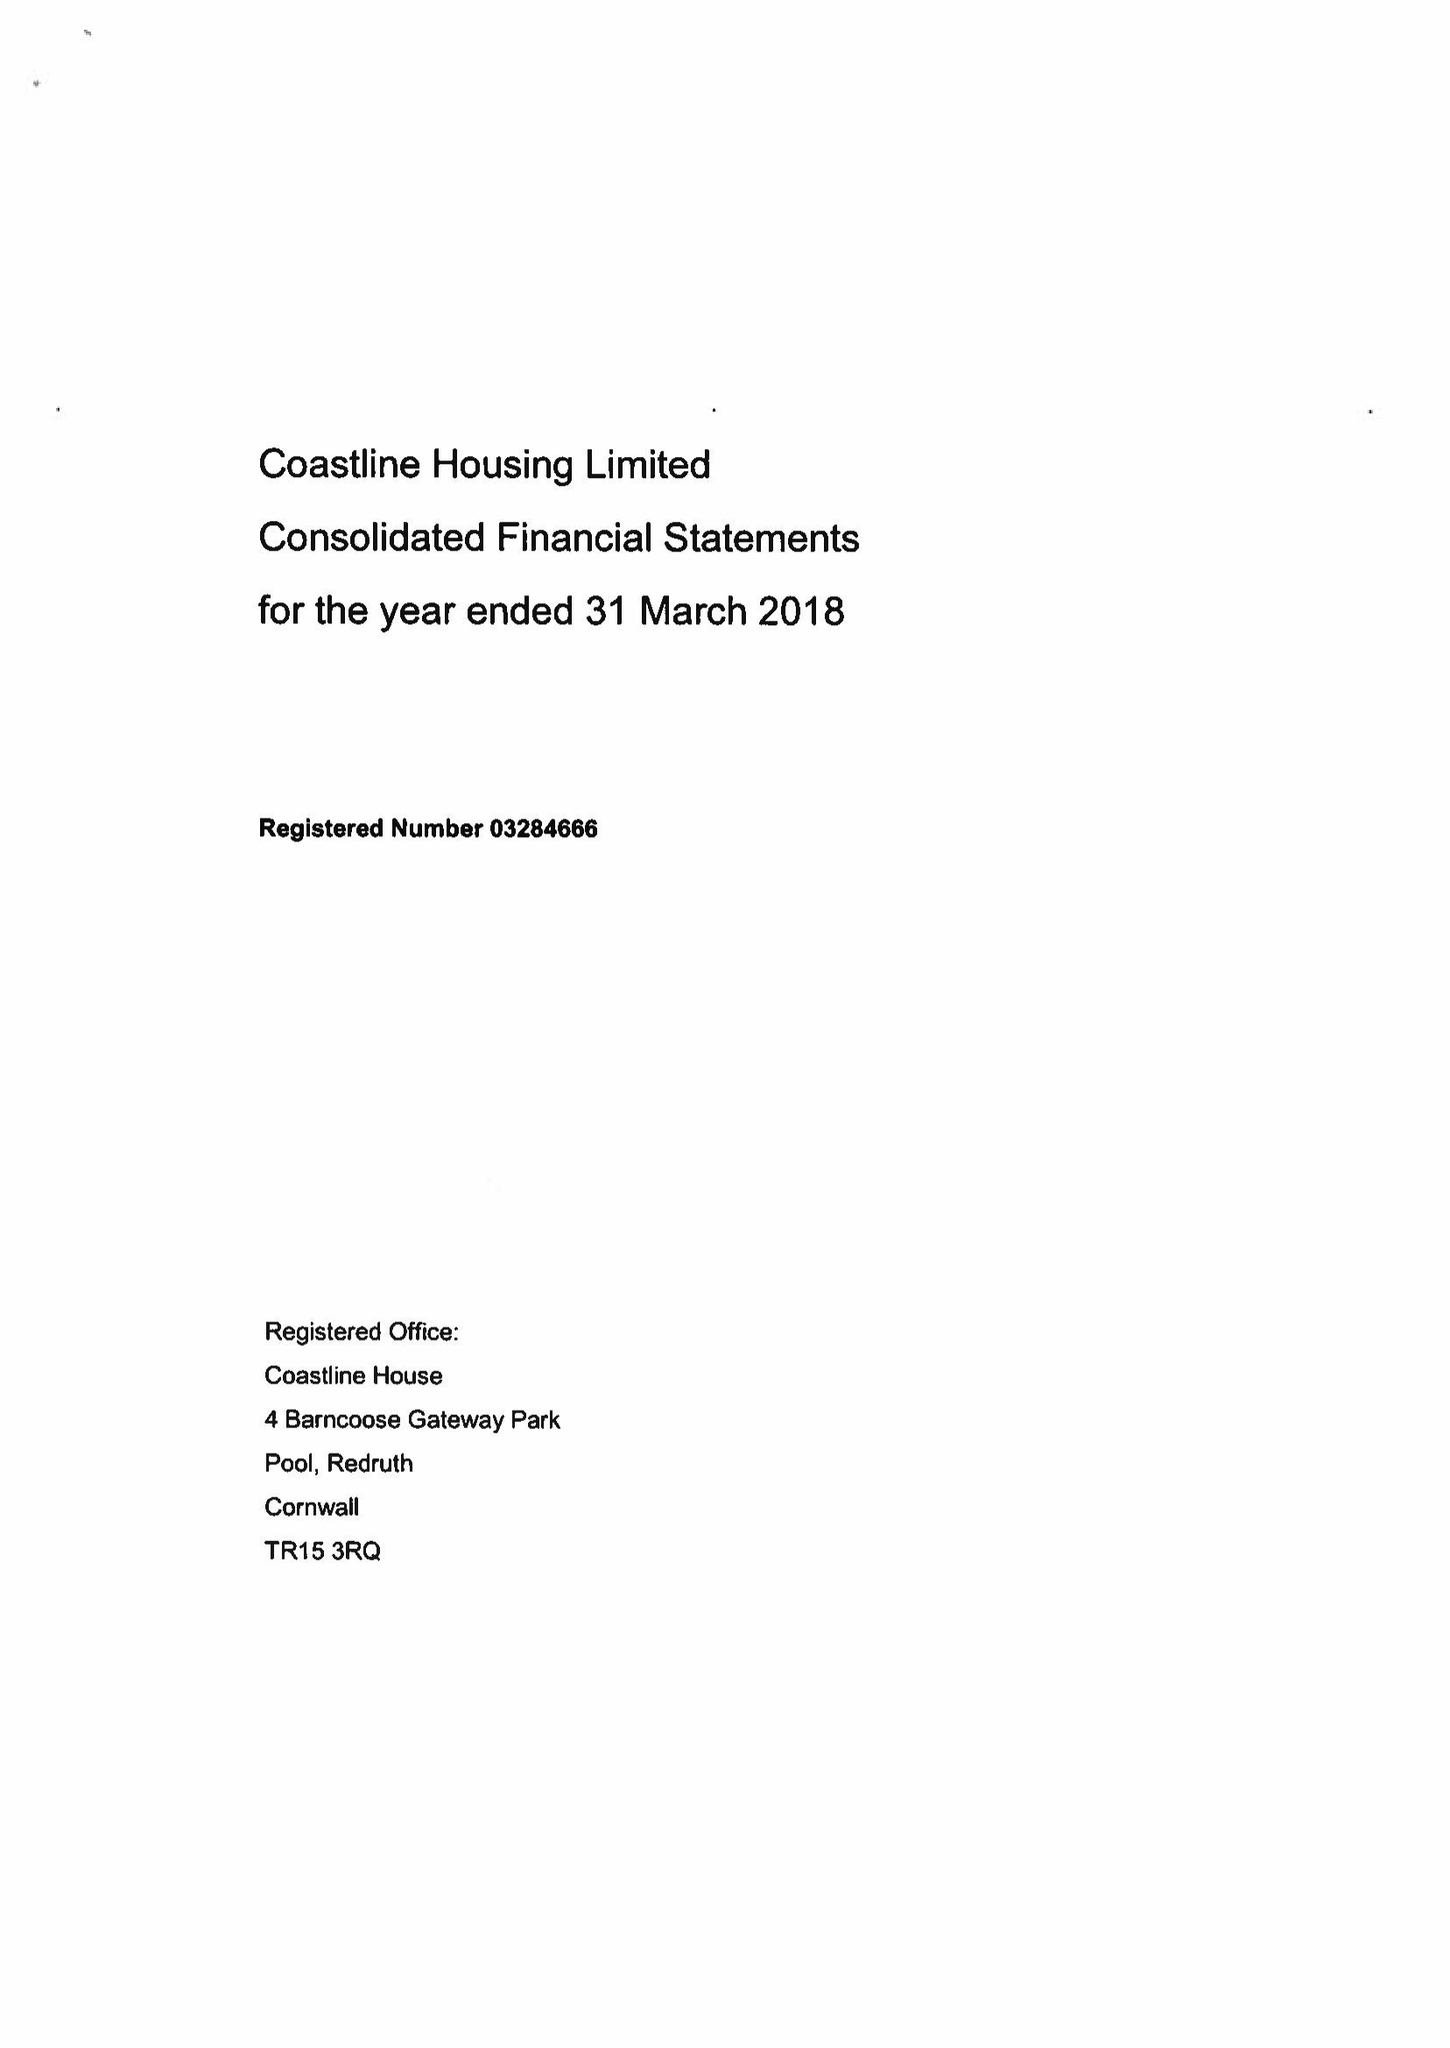What is the value for the charity_number?
Answer the question using a single word or phrase. 1066916 